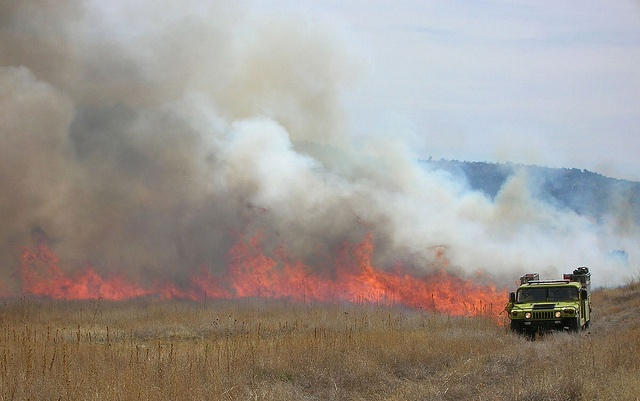Describe the objects in this image and their specific colors. I can see a truck in gray, black, darkgreen, and olive tones in this image. 